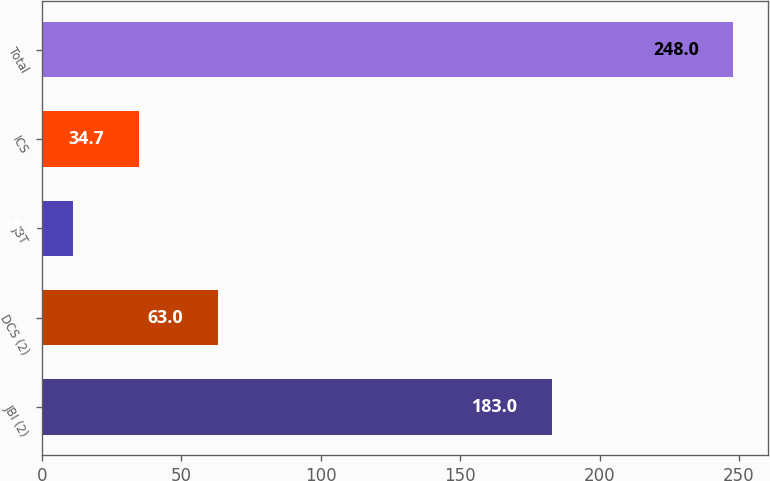Convert chart. <chart><loc_0><loc_0><loc_500><loc_500><bar_chart><fcel>JBI (2)<fcel>DCS (2)<fcel>JBT<fcel>ICS<fcel>Total<nl><fcel>183<fcel>63<fcel>11<fcel>34.7<fcel>248<nl></chart> 